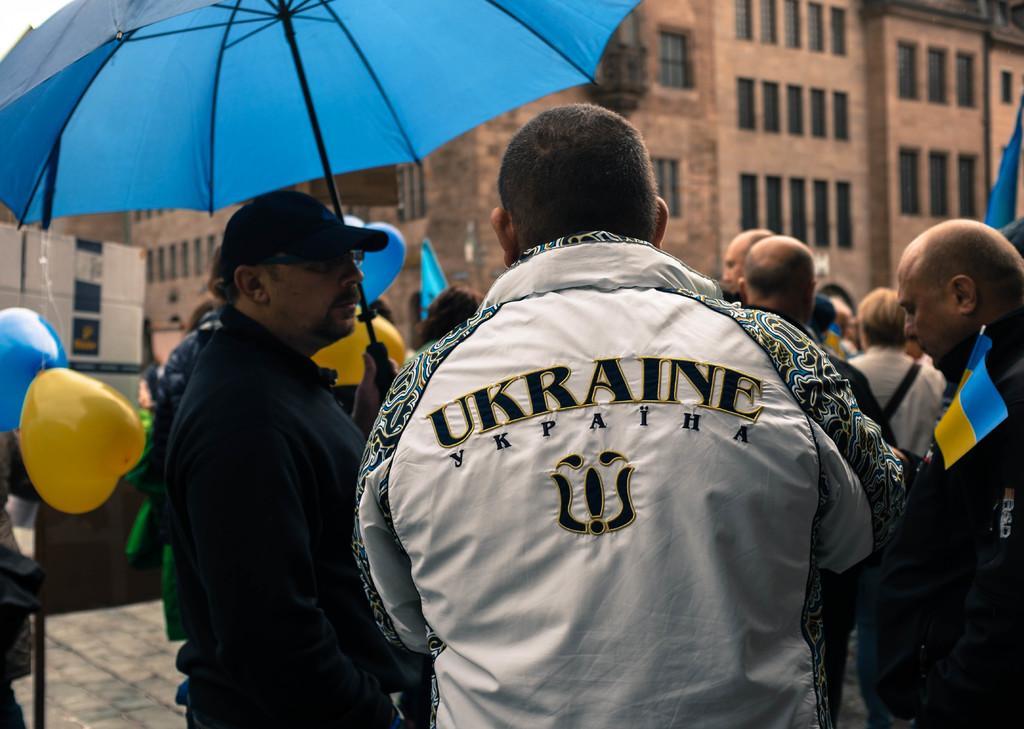Describe this image in one or two sentences. In this image I can see in the middle a person is standing, this person wears a white color coat. There is a name on it, on the left side a man is standing by holding an umbrella, it is in blue color. There are balloons beside of him, at the top there is a building. 